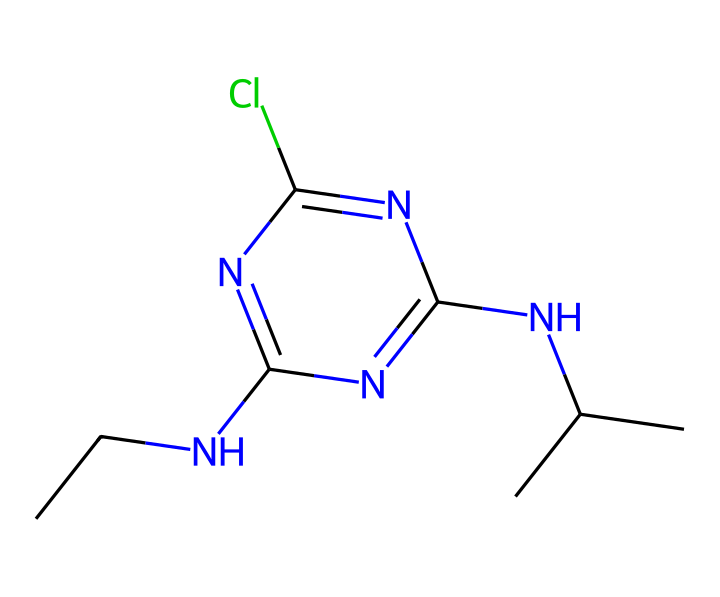What is the molecular weight of atrazine? To calculate the molecular weight, we add up the atomic weights of all the atoms present in the structure based on the SMILES representation. The structure contains carbon (C), nitrogen (N), and chlorine (Cl) atoms. Counting and using standard atomic weights (C = 12.01, H = 1.01, N = 14.01, Cl = 35.45), we find the molecular weight is approximately 215.68 g/mol.
Answer: 215.68 g/mol How many nitrogen atoms are present in atrazine? By examining the structure from the SMILES representation, we identify the nitrogen (N) atoms. There are three nitrogen atoms depicted in the structure.
Answer: 3 Does atrazine contain any halogens? Halogens are elements in group 17 of the periodic table, including fluorine, chlorine, bromine, iodine, and astatine. In this structure, we see a chlorine (Cl) atom.
Answer: Yes What type of herbicide is atrazine classified as? Atrazine is classified as a triazine herbicide, identified by its molecular structure which includes a triazine ring (three nitrogen atoms in a six-membered ring).
Answer: triazine How many carbon atoms are in the atrazine structure? Counting the carbon (C) atoms in the SMILES representation, we observe that there are six carbon atoms present in the chemical structure.
Answer: 6 What functional group is present in atrazine? The atrazine structure contains an amine group (–NH) due to the presence of nitrogen connected to carbon. This is indicative of its functionality as a herbicide.
Answer: amine What is the primary environmental concern regarding atrazine? Atrazine is known for its potential to contaminate water sources, leading to environmental pollution and impacts on aquatic ecosystems.
Answer: water contamination 